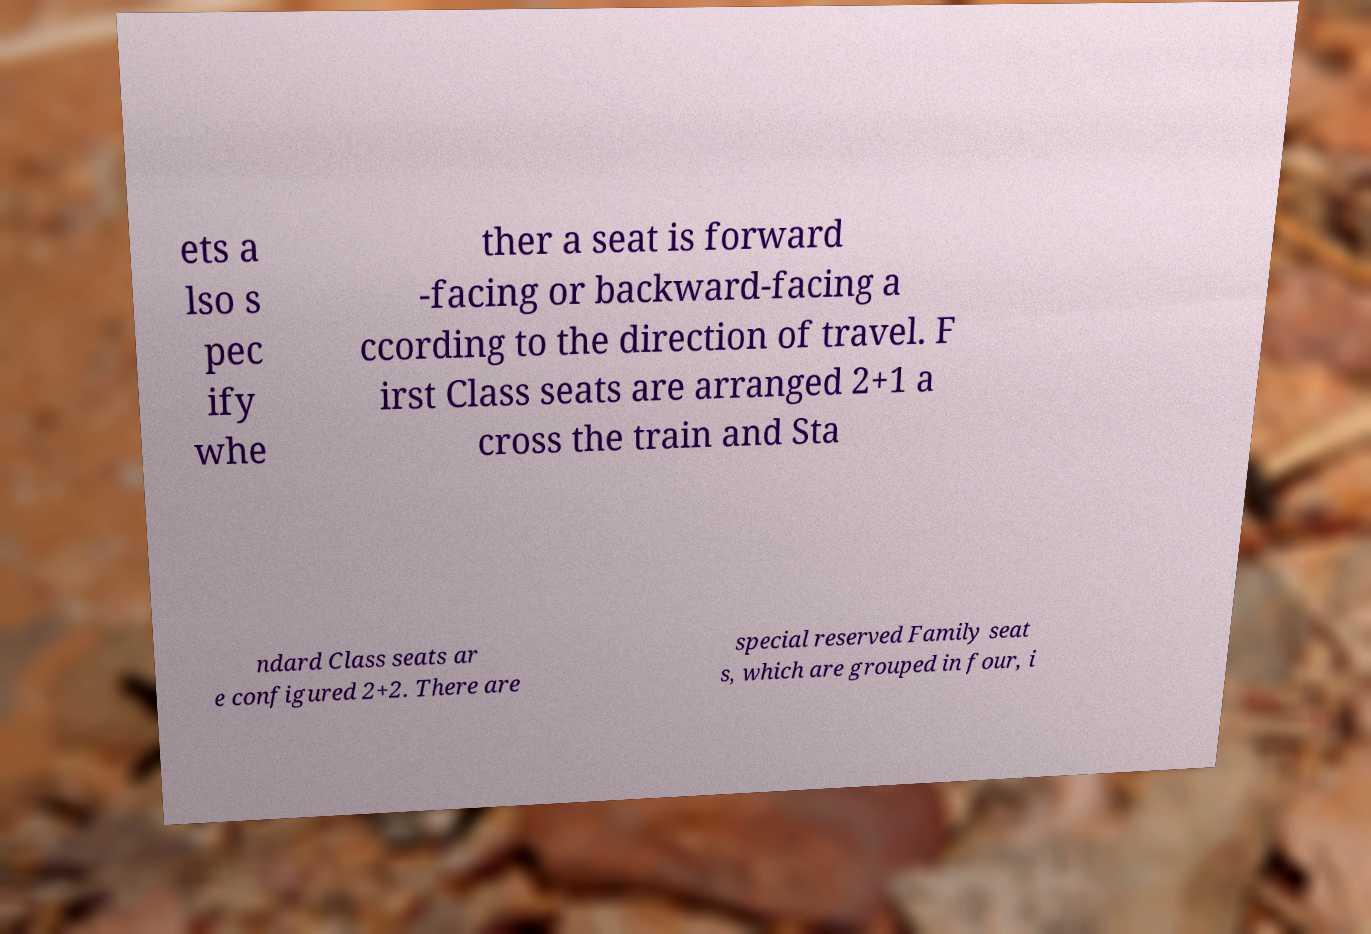Could you extract and type out the text from this image? ets a lso s pec ify whe ther a seat is forward -facing or backward-facing a ccording to the direction of travel. F irst Class seats are arranged 2+1 a cross the train and Sta ndard Class seats ar e configured 2+2. There are special reserved Family seat s, which are grouped in four, i 